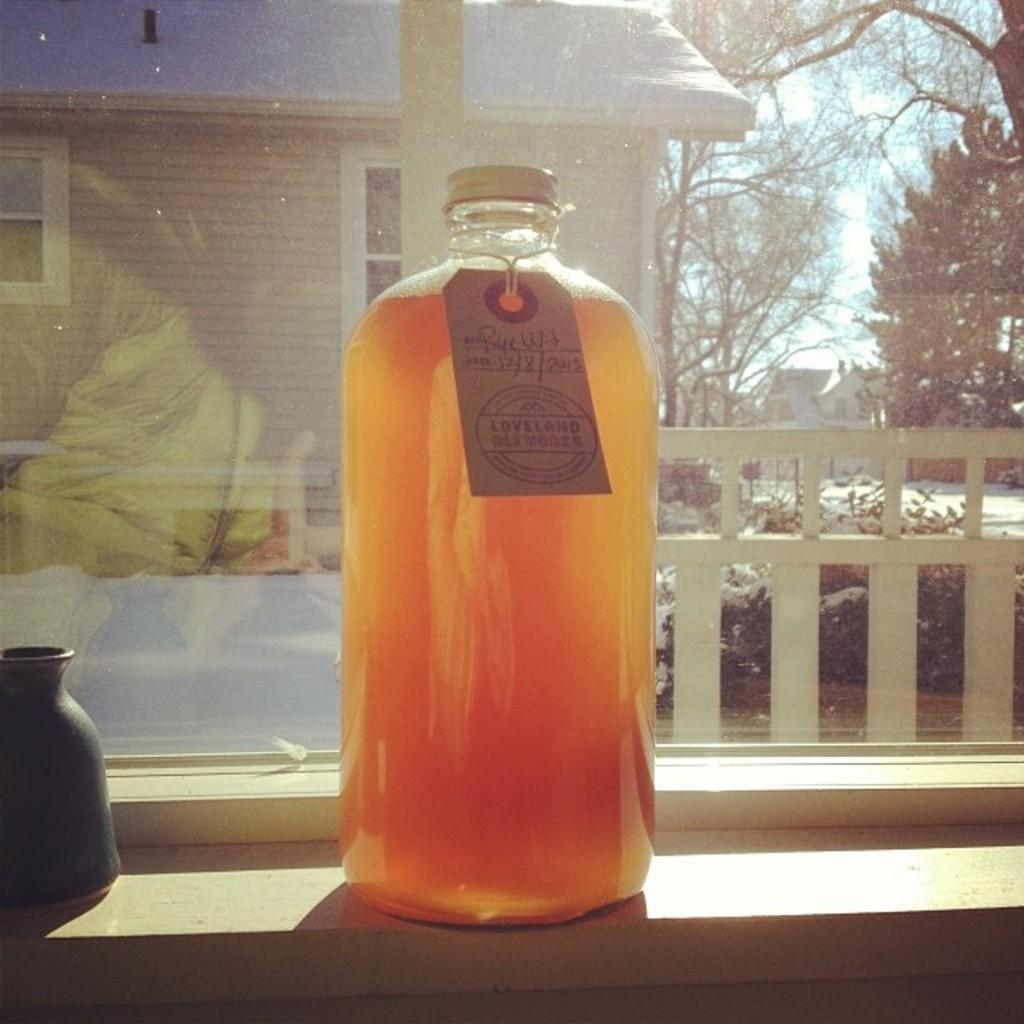Provide a one-sentence caption for the provided image. Large orange bottle of jam from Loveland placed by a window. 